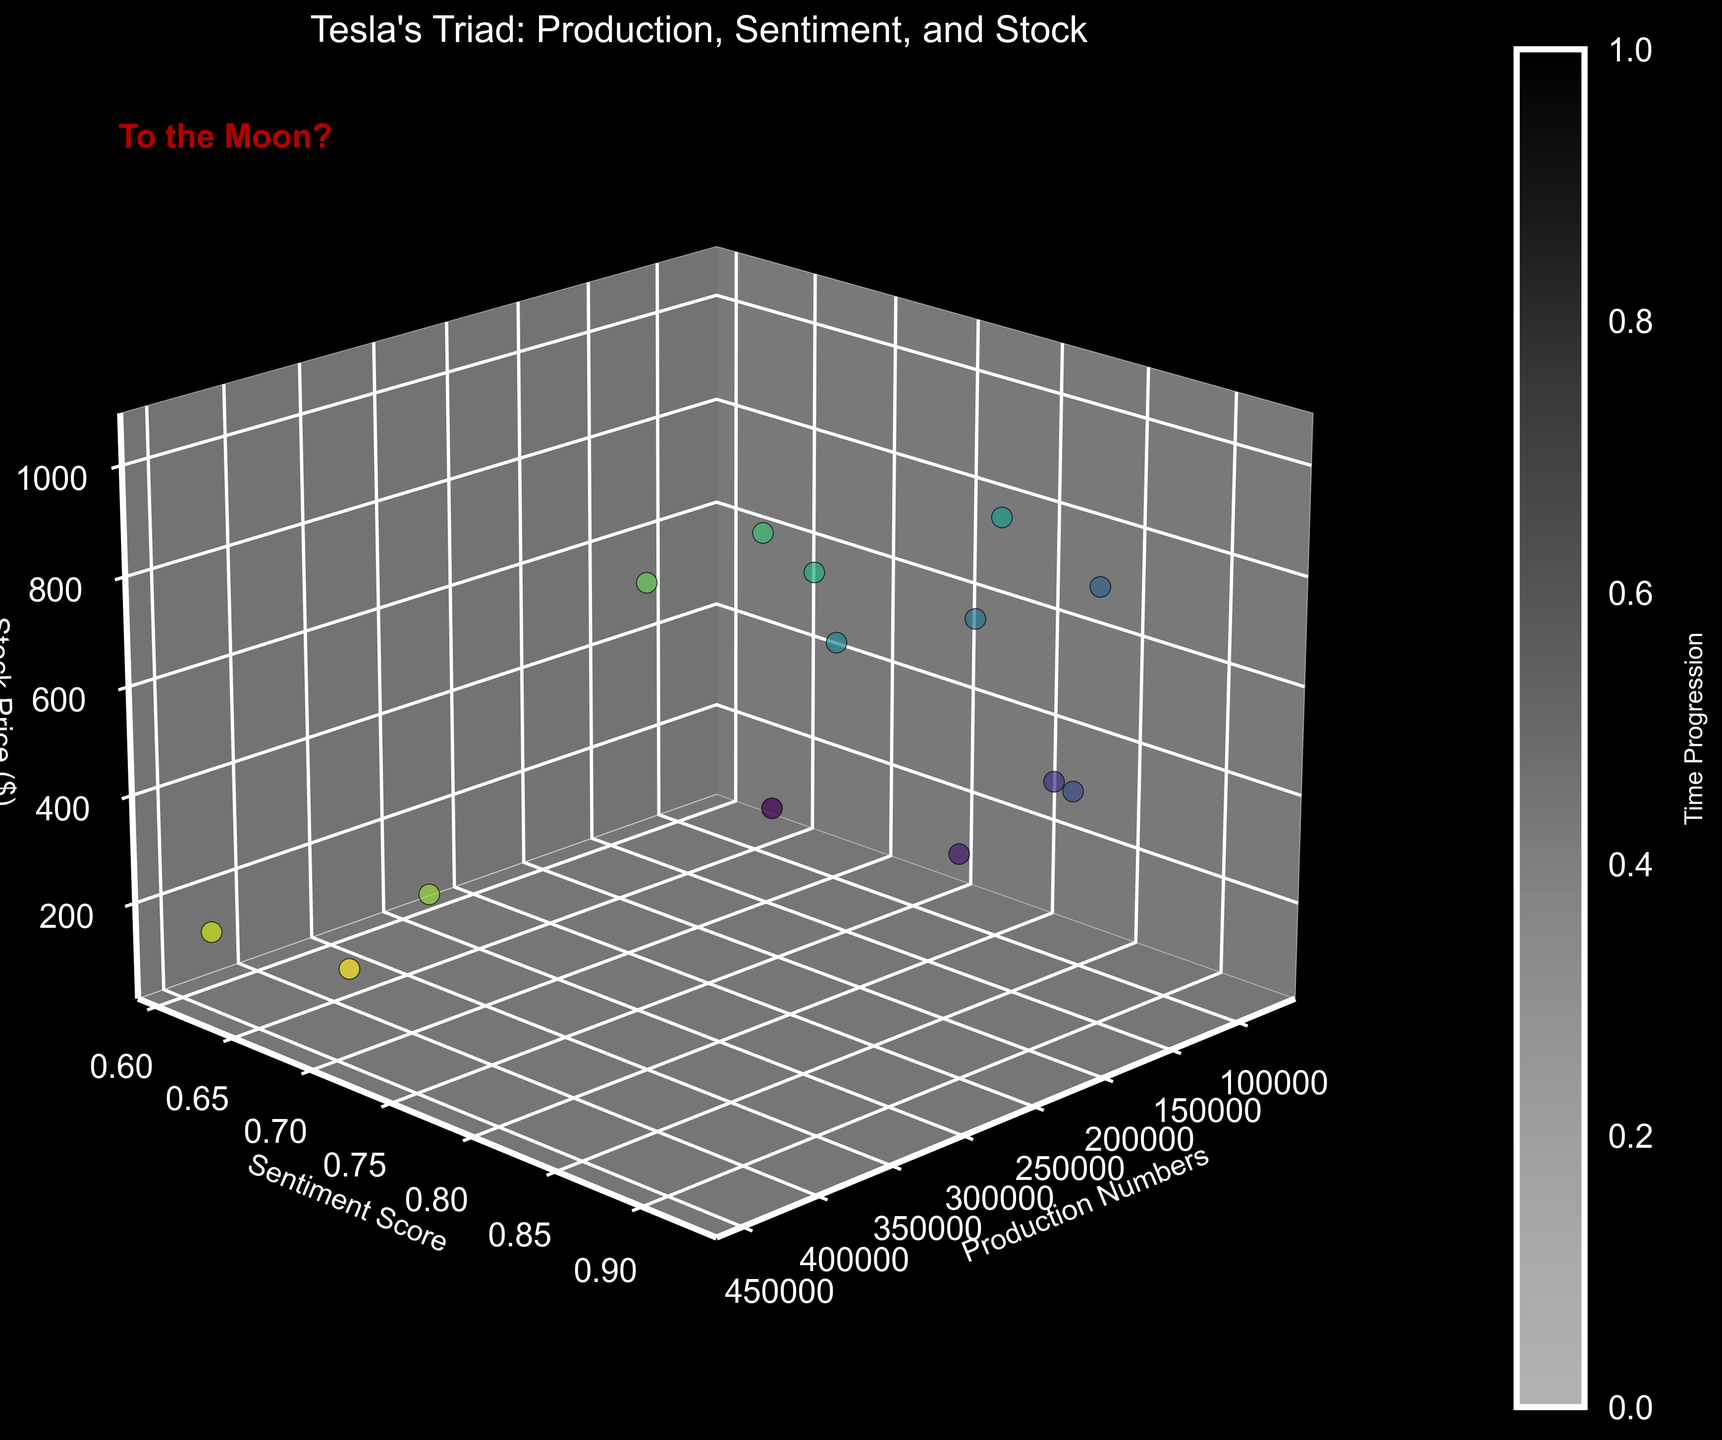What is the title of the 3D scatter plot? The title is written at the top of the plot. Here, it reads "Tesla's Triad: Production, Sentiment, and Stock."
Answer: Tesla's Triad: Production, Sentiment, and Stock How many data points are visualized in the plot? Each scatter point represents a unique data point. If we count the number of distinct points, we will find there are 14 data points.
Answer: 14 Which axis represents the Production Numbers? The axis labels identify what each axis represents: the 'x' axis is labeled 'Production Numbers.'
Answer: x-axis Between the highest and lowest stock prices, what is the difference? The highest stock price is approximately $1024.86, and the lowest is about $88.60. The difference is calculated by subtracting the lowest from the highest: 1024.86 - 88.60 = 936.26.
Answer: 936.26 Which part of the figure indicates time progression? The color bar on the side of the plot represents time progression, as labeled by "Time Progression."
Answer: Color bar Is there any visible correlation between Sentiment Scores and Stock Prices? By observing the plot, we see that as the sentiment scores increase, the stock prices also tend to increase, indicating a positive correlation.
Answer: Positive correlation What is the sentiment score of the point with the highest production number? The scatter point at the highest production number (440,808) has a sentiment score of approximately 0.70 as observed from the plot.
Answer: 0.70 Compare the stock prices when the sentiment scores were 0.65 and 0.88. Which is higher? The plot shows the stock price for a sentiment score of 0.65 is about $88.60, and for 0.88, it is around $422.64. Therefore, the stock price is higher at the sentiment score of 0.88.
Answer: Stock price at sentiment score 0.88 Which month had the highest stock price, and what was the production number at that time? By cross-referencing the scatter points, the highest stock price is approximately $1024.86, which occurred in October 2021 with a production number of 237,823.
Answer: October 2021, 237,823 Is there a trend between production numbers and stock prices? Observing the scatter plot, as production numbers increase, stock prices also generally increase, suggesting a positive trend.
Answer: Positive trend 